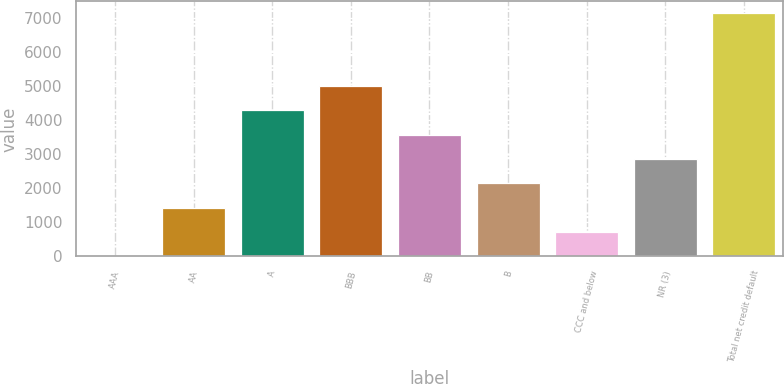Convert chart to OTSL. <chart><loc_0><loc_0><loc_500><loc_500><bar_chart><fcel>AAA<fcel>AA<fcel>A<fcel>BBB<fcel>BB<fcel>B<fcel>CCC and below<fcel>NR (3)<fcel>Total net credit default<nl><fcel>13<fcel>1439.6<fcel>4292.8<fcel>5006.1<fcel>3579.5<fcel>2152.9<fcel>726.3<fcel>2866.2<fcel>7146<nl></chart> 